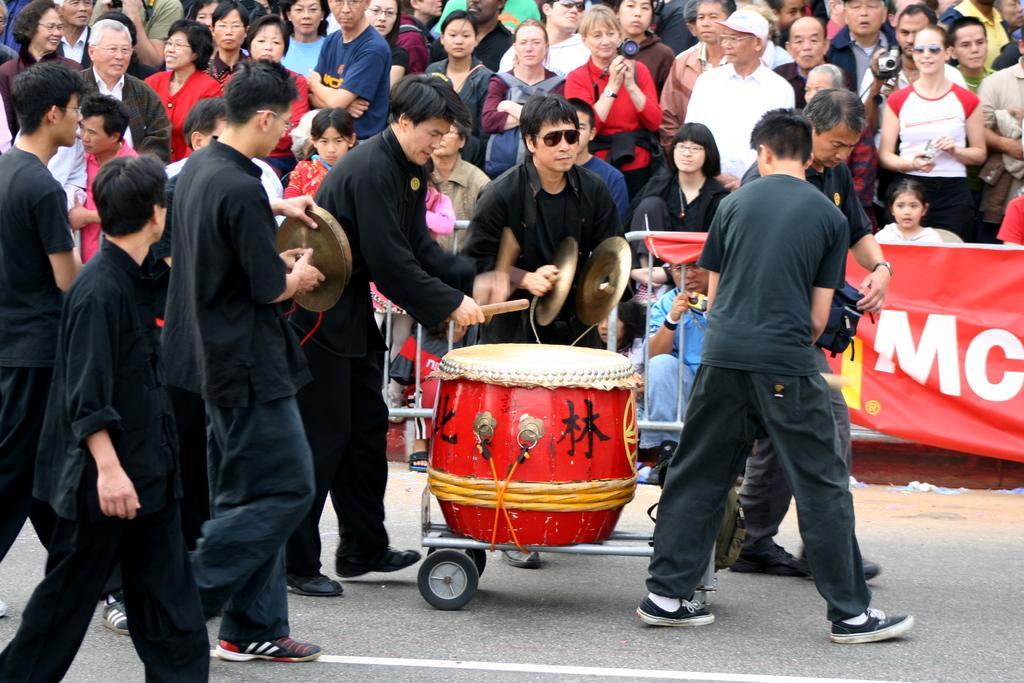In one or two sentences, can you explain what this image depicts? This image consists of a group of persons. In the center man is holding a instrument in his hand. At the left side man is playing a drum. In the background there are crowd, there is a banner red in colour. 